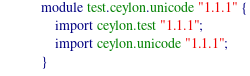<code> <loc_0><loc_0><loc_500><loc_500><_Ceylon_>module test.ceylon.unicode "1.1.1" {
    import ceylon.test "1.1.1";
    import ceylon.unicode "1.1.1";
}</code> 